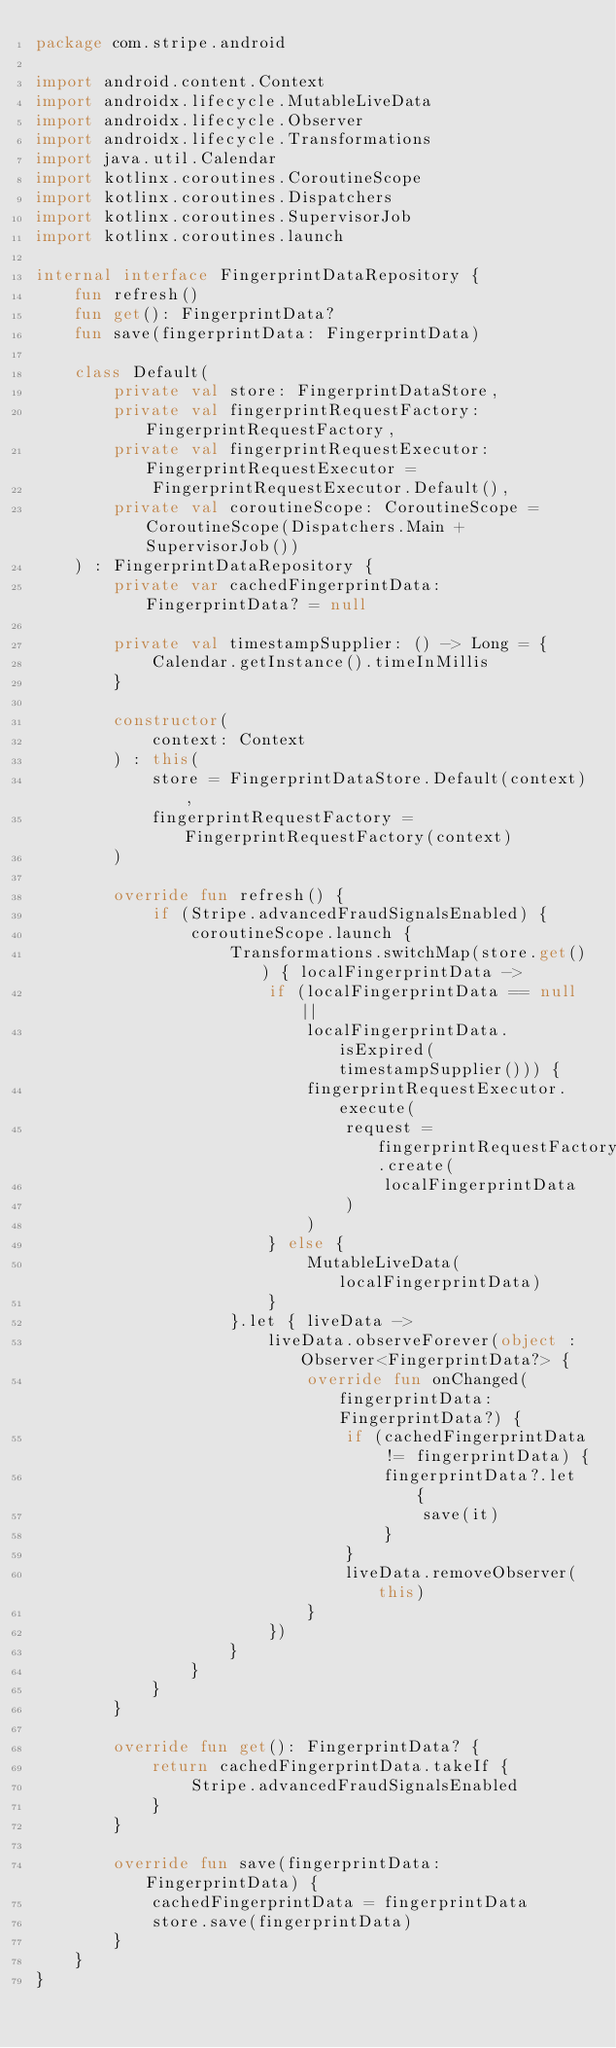Convert code to text. <code><loc_0><loc_0><loc_500><loc_500><_Kotlin_>package com.stripe.android

import android.content.Context
import androidx.lifecycle.MutableLiveData
import androidx.lifecycle.Observer
import androidx.lifecycle.Transformations
import java.util.Calendar
import kotlinx.coroutines.CoroutineScope
import kotlinx.coroutines.Dispatchers
import kotlinx.coroutines.SupervisorJob
import kotlinx.coroutines.launch

internal interface FingerprintDataRepository {
    fun refresh()
    fun get(): FingerprintData?
    fun save(fingerprintData: FingerprintData)

    class Default(
        private val store: FingerprintDataStore,
        private val fingerprintRequestFactory: FingerprintRequestFactory,
        private val fingerprintRequestExecutor: FingerprintRequestExecutor =
            FingerprintRequestExecutor.Default(),
        private val coroutineScope: CoroutineScope = CoroutineScope(Dispatchers.Main + SupervisorJob())
    ) : FingerprintDataRepository {
        private var cachedFingerprintData: FingerprintData? = null

        private val timestampSupplier: () -> Long = {
            Calendar.getInstance().timeInMillis
        }

        constructor(
            context: Context
        ) : this(
            store = FingerprintDataStore.Default(context),
            fingerprintRequestFactory = FingerprintRequestFactory(context)
        )

        override fun refresh() {
            if (Stripe.advancedFraudSignalsEnabled) {
                coroutineScope.launch {
                    Transformations.switchMap(store.get()) { localFingerprintData ->
                        if (localFingerprintData == null ||
                            localFingerprintData.isExpired(timestampSupplier())) {
                            fingerprintRequestExecutor.execute(
                                request = fingerprintRequestFactory.create(
                                    localFingerprintData
                                )
                            )
                        } else {
                            MutableLiveData(localFingerprintData)
                        }
                    }.let { liveData ->
                        liveData.observeForever(object : Observer<FingerprintData?> {
                            override fun onChanged(fingerprintData: FingerprintData?) {
                                if (cachedFingerprintData != fingerprintData) {
                                    fingerprintData?.let {
                                        save(it)
                                    }
                                }
                                liveData.removeObserver(this)
                            }
                        })
                    }
                }
            }
        }

        override fun get(): FingerprintData? {
            return cachedFingerprintData.takeIf {
                Stripe.advancedFraudSignalsEnabled
            }
        }

        override fun save(fingerprintData: FingerprintData) {
            cachedFingerprintData = fingerprintData
            store.save(fingerprintData)
        }
    }
}
</code> 